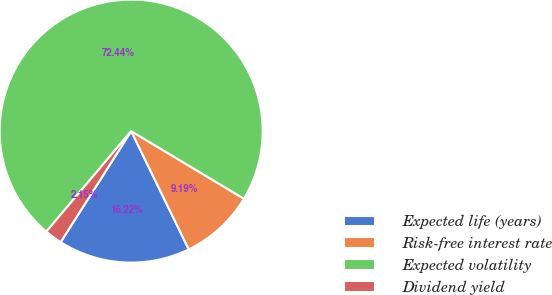Convert chart to OTSL. <chart><loc_0><loc_0><loc_500><loc_500><pie_chart><fcel>Expected life (years)<fcel>Risk-free interest rate<fcel>Expected volatility<fcel>Dividend yield<nl><fcel>16.22%<fcel>9.19%<fcel>72.44%<fcel>2.15%<nl></chart> 